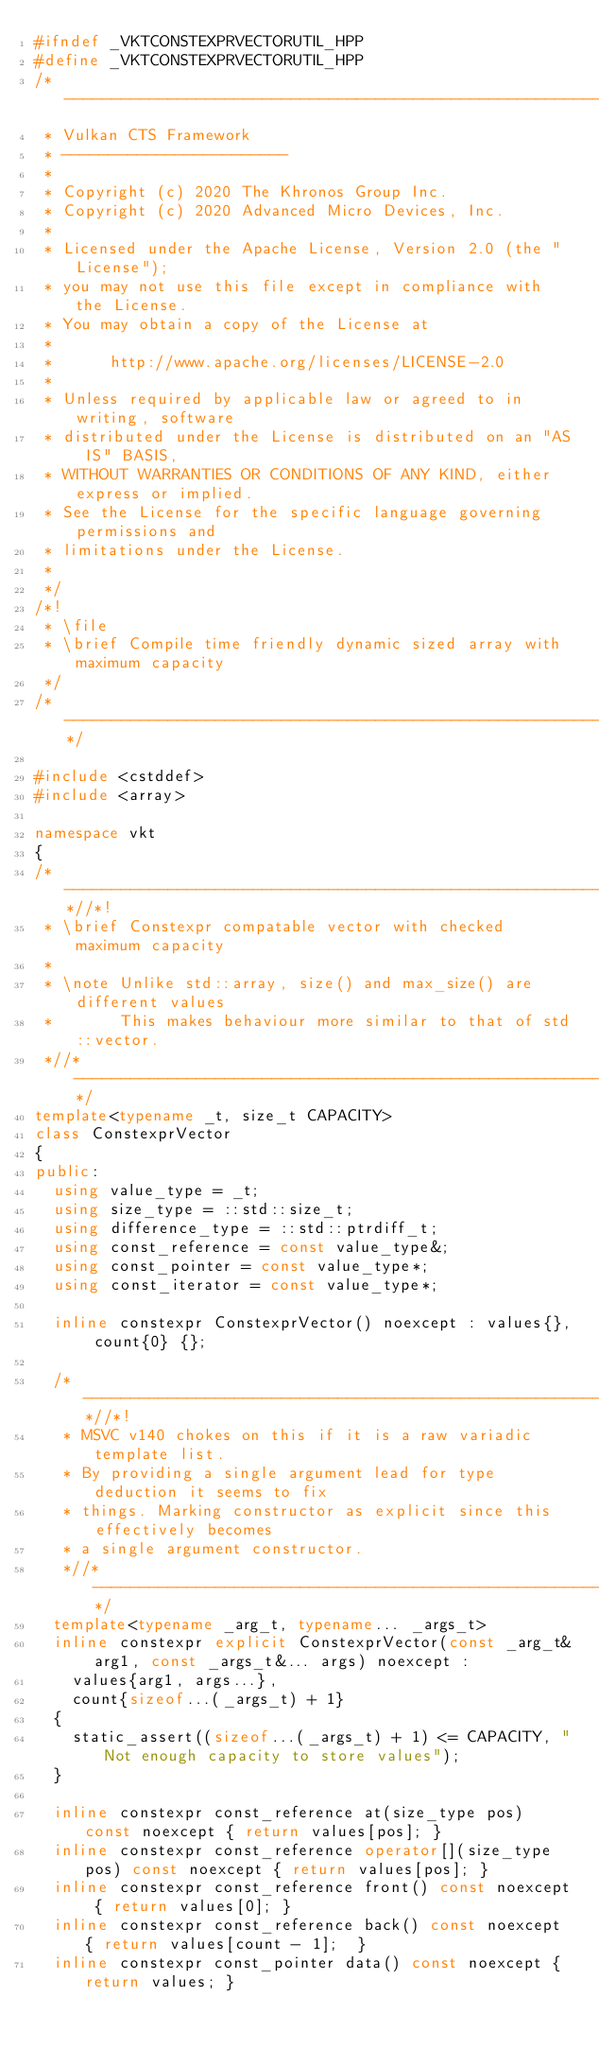Convert code to text. <code><loc_0><loc_0><loc_500><loc_500><_C++_>#ifndef _VKTCONSTEXPRVECTORUTIL_HPP
#define _VKTCONSTEXPRVECTORUTIL_HPP
/*------------------------------------------------------------------------
 * Vulkan CTS Framework
 * ------------------------
 *
 * Copyright (c) 2020 The Khronos Group Inc.
 * Copyright (c) 2020 Advanced Micro Devices, Inc.
 *
 * Licensed under the Apache License, Version 2.0 (the "License");
 * you may not use this file except in compliance with the License.
 * You may obtain a copy of the License at
 *
 *      http://www.apache.org/licenses/LICENSE-2.0
 *
 * Unless required by applicable law or agreed to in writing, software
 * distributed under the License is distributed on an "AS IS" BASIS,
 * WITHOUT WARRANTIES OR CONDITIONS OF ANY KIND, either express or implied.
 * See the License for the specific language governing permissions and
 * limitations under the License.
 *
 */
/*!
 * \file
 * \brief Compile time friendly dynamic sized array with maximum capacity
 */
/*--------------------------------------------------------------------*/

#include <cstddef>
#include <array>

namespace vkt
{
/*--------------------------------------------------------------------*//*!
 * \brief Constexpr compatable vector with checked maximum capacity
 *
 * \note Unlike std::array, size() and max_size() are different values
 *       This makes behaviour more similar to that of std::vector.
 *//*--------------------------------------------------------------------*/
template<typename _t, size_t CAPACITY>
class ConstexprVector
{
public:
	using value_type = _t;
	using size_type = ::std::size_t;
	using difference_type = ::std::ptrdiff_t;
	using const_reference = const value_type&;
	using const_pointer = const value_type*;
	using const_iterator = const value_type*;

	inline constexpr ConstexprVector() noexcept : values{}, count{0} {};

	/*--------------------------------------------------------------------*//*!
	 * MSVC v140 chokes on this if it is a raw variadic template list.
	 * By providing a single argument lead for type deduction it seems to fix
	 * things. Marking constructor as explicit since this effectively becomes
	 * a single argument constructor.
	 *//*--------------------------------------------------------------------*/
	template<typename _arg_t, typename... _args_t>
	inline constexpr explicit ConstexprVector(const _arg_t& arg1, const _args_t&... args) noexcept :
		values{arg1, args...},
		count{sizeof...(_args_t) + 1}
	{
		static_assert((sizeof...(_args_t) + 1) <= CAPACITY, "Not enough capacity to store values");
	}

	inline constexpr const_reference at(size_type pos) const noexcept { return values[pos]; }
	inline constexpr const_reference operator[](size_type pos) const noexcept { return values[pos]; }
	inline constexpr const_reference front() const noexcept { return values[0]; }
	inline constexpr const_reference back() const noexcept { return values[count - 1];	}
	inline constexpr const_pointer data() const noexcept { return values; }</code> 